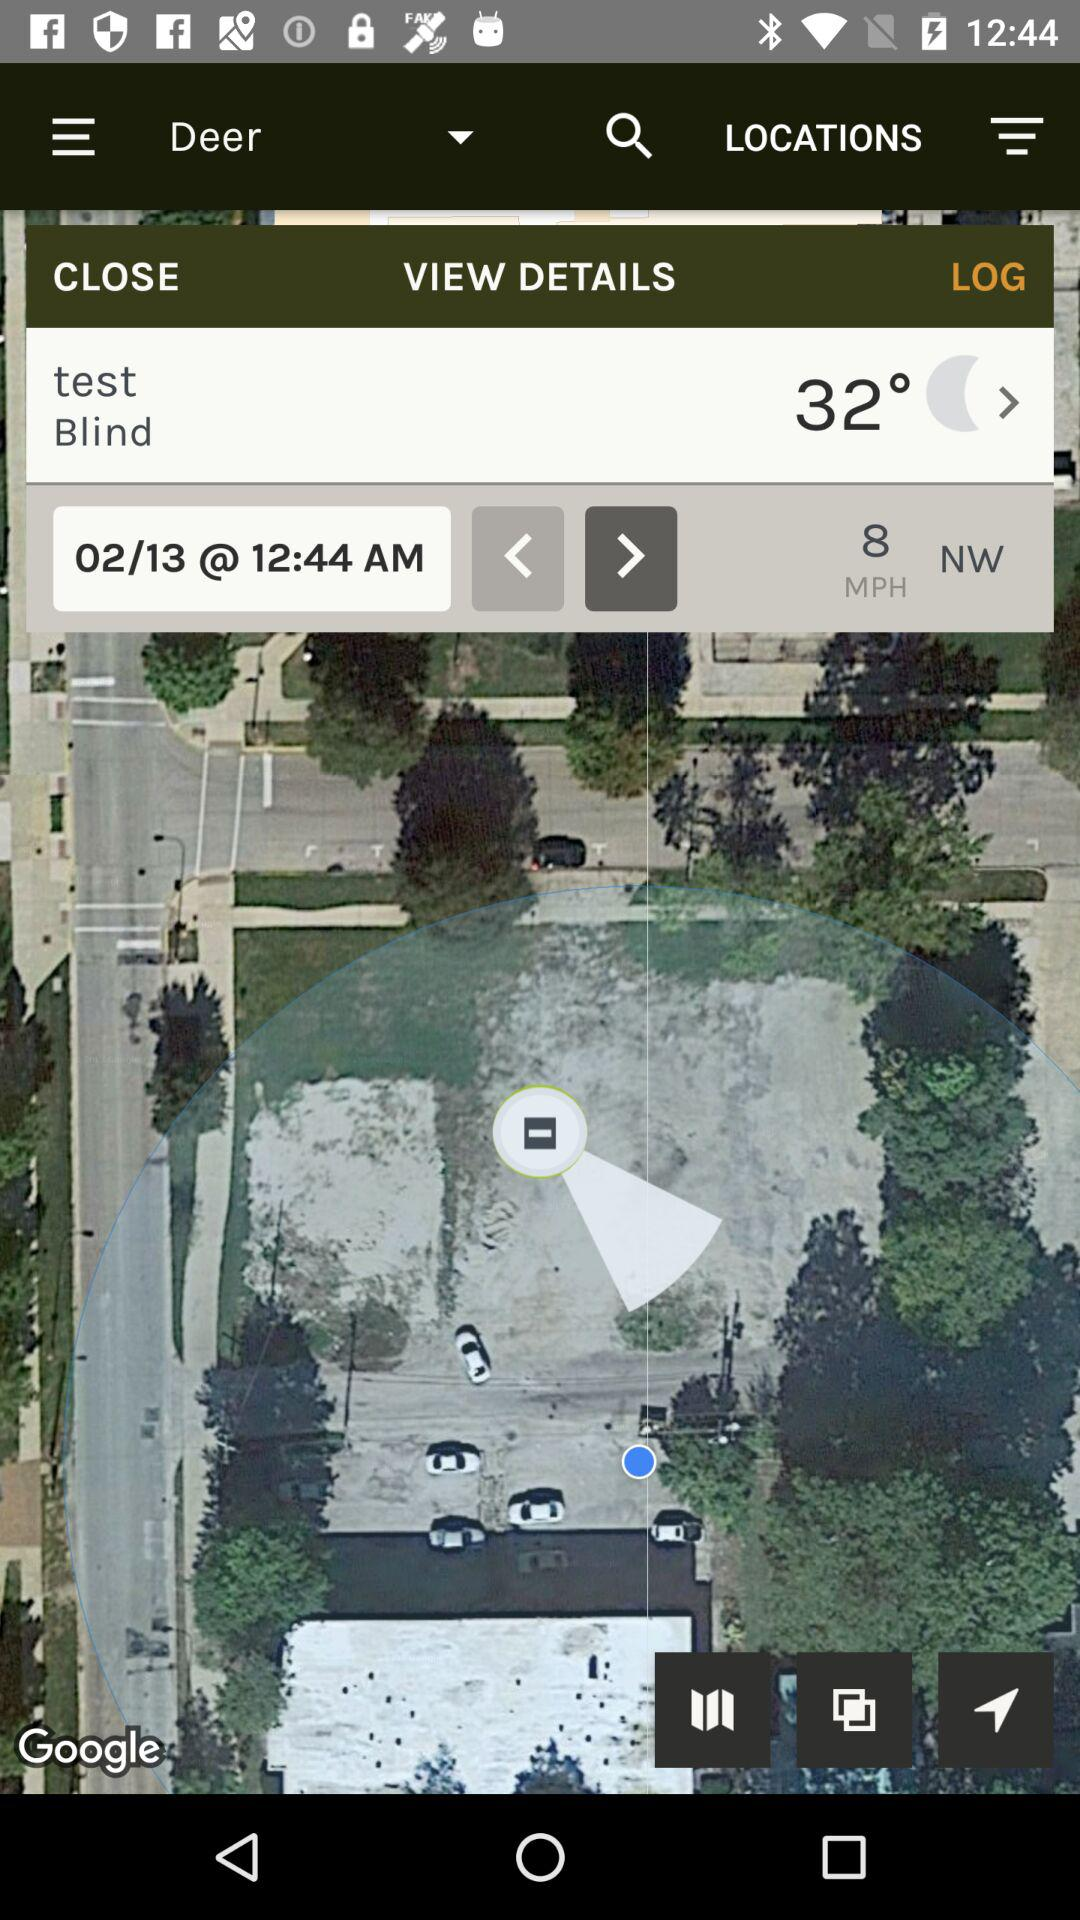What is the temperature? The temperature is 32°. 